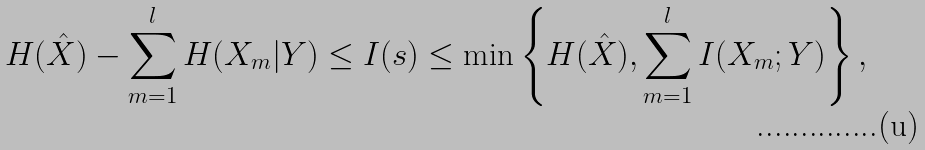<formula> <loc_0><loc_0><loc_500><loc_500>H ( \hat { X } ) - \sum _ { m = 1 } ^ { l } { H ( X _ { m } | Y ) } \leq I ( s ) \leq \min \left \{ H ( \hat { X } ) , \sum _ { m = 1 } ^ { l } I ( X _ { m } ; Y ) \right \} ,</formula> 